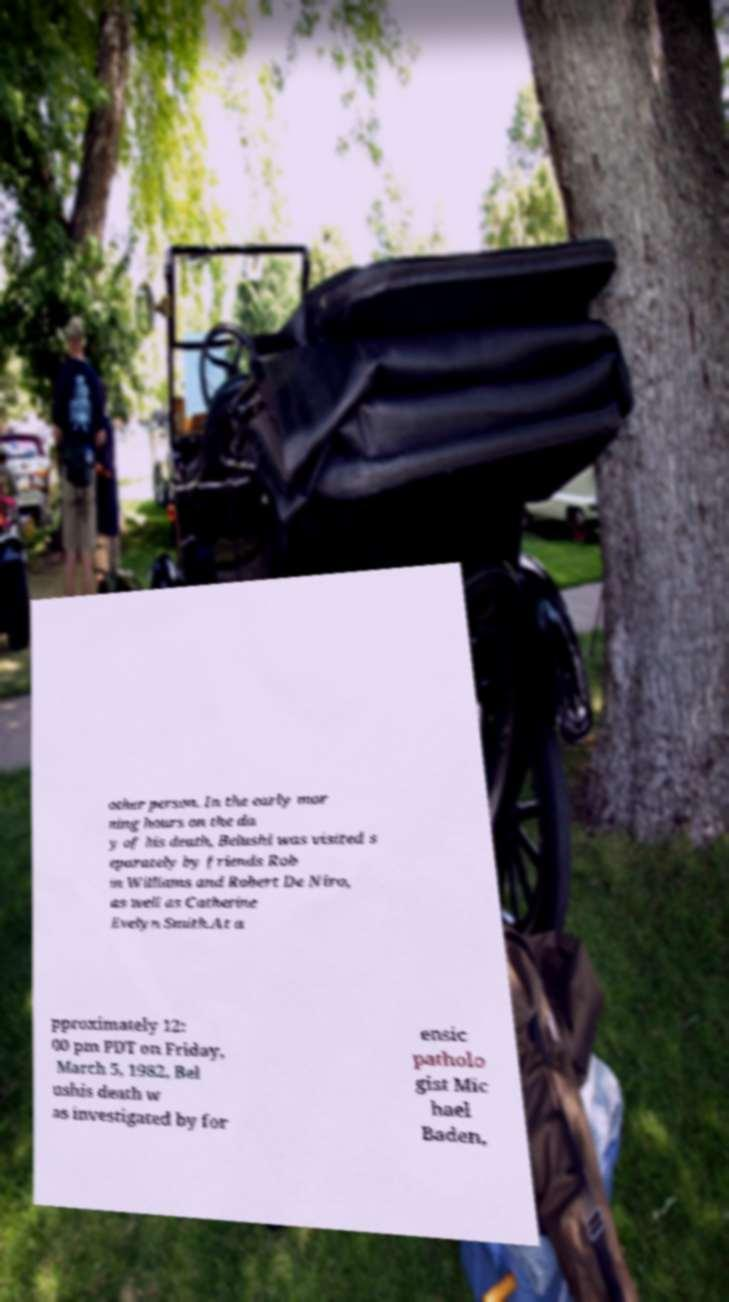Please identify and transcribe the text found in this image. other person. In the early mor ning hours on the da y of his death, Belushi was visited s eparately by friends Rob in Williams and Robert De Niro, as well as Catherine Evelyn Smith.At a pproximately 12: 00 pm PDT on Friday, March 5, 1982, Bel ushis death w as investigated by for ensic patholo gist Mic hael Baden, 